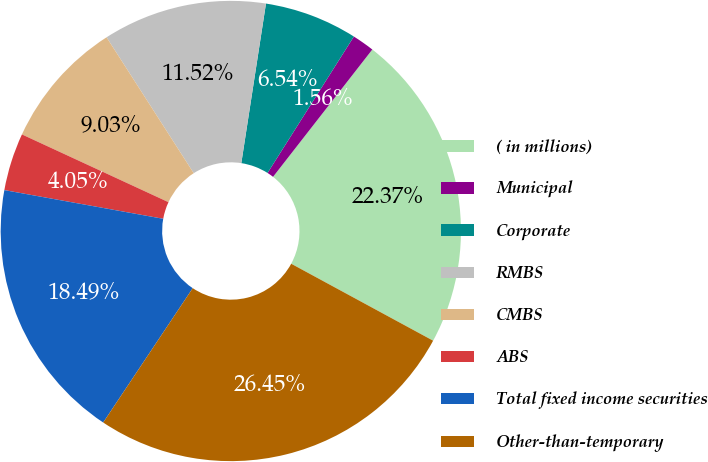Convert chart. <chart><loc_0><loc_0><loc_500><loc_500><pie_chart><fcel>( in millions)<fcel>Municipal<fcel>Corporate<fcel>RMBS<fcel>CMBS<fcel>ABS<fcel>Total fixed income securities<fcel>Other-than-temporary<nl><fcel>22.37%<fcel>1.56%<fcel>6.54%<fcel>11.52%<fcel>9.03%<fcel>4.05%<fcel>18.49%<fcel>26.45%<nl></chart> 